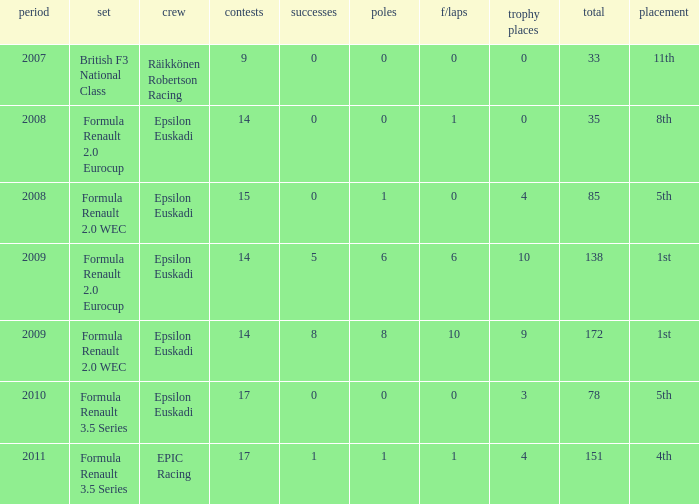What team was he on when he had 10 f/laps? Epsilon Euskadi. 